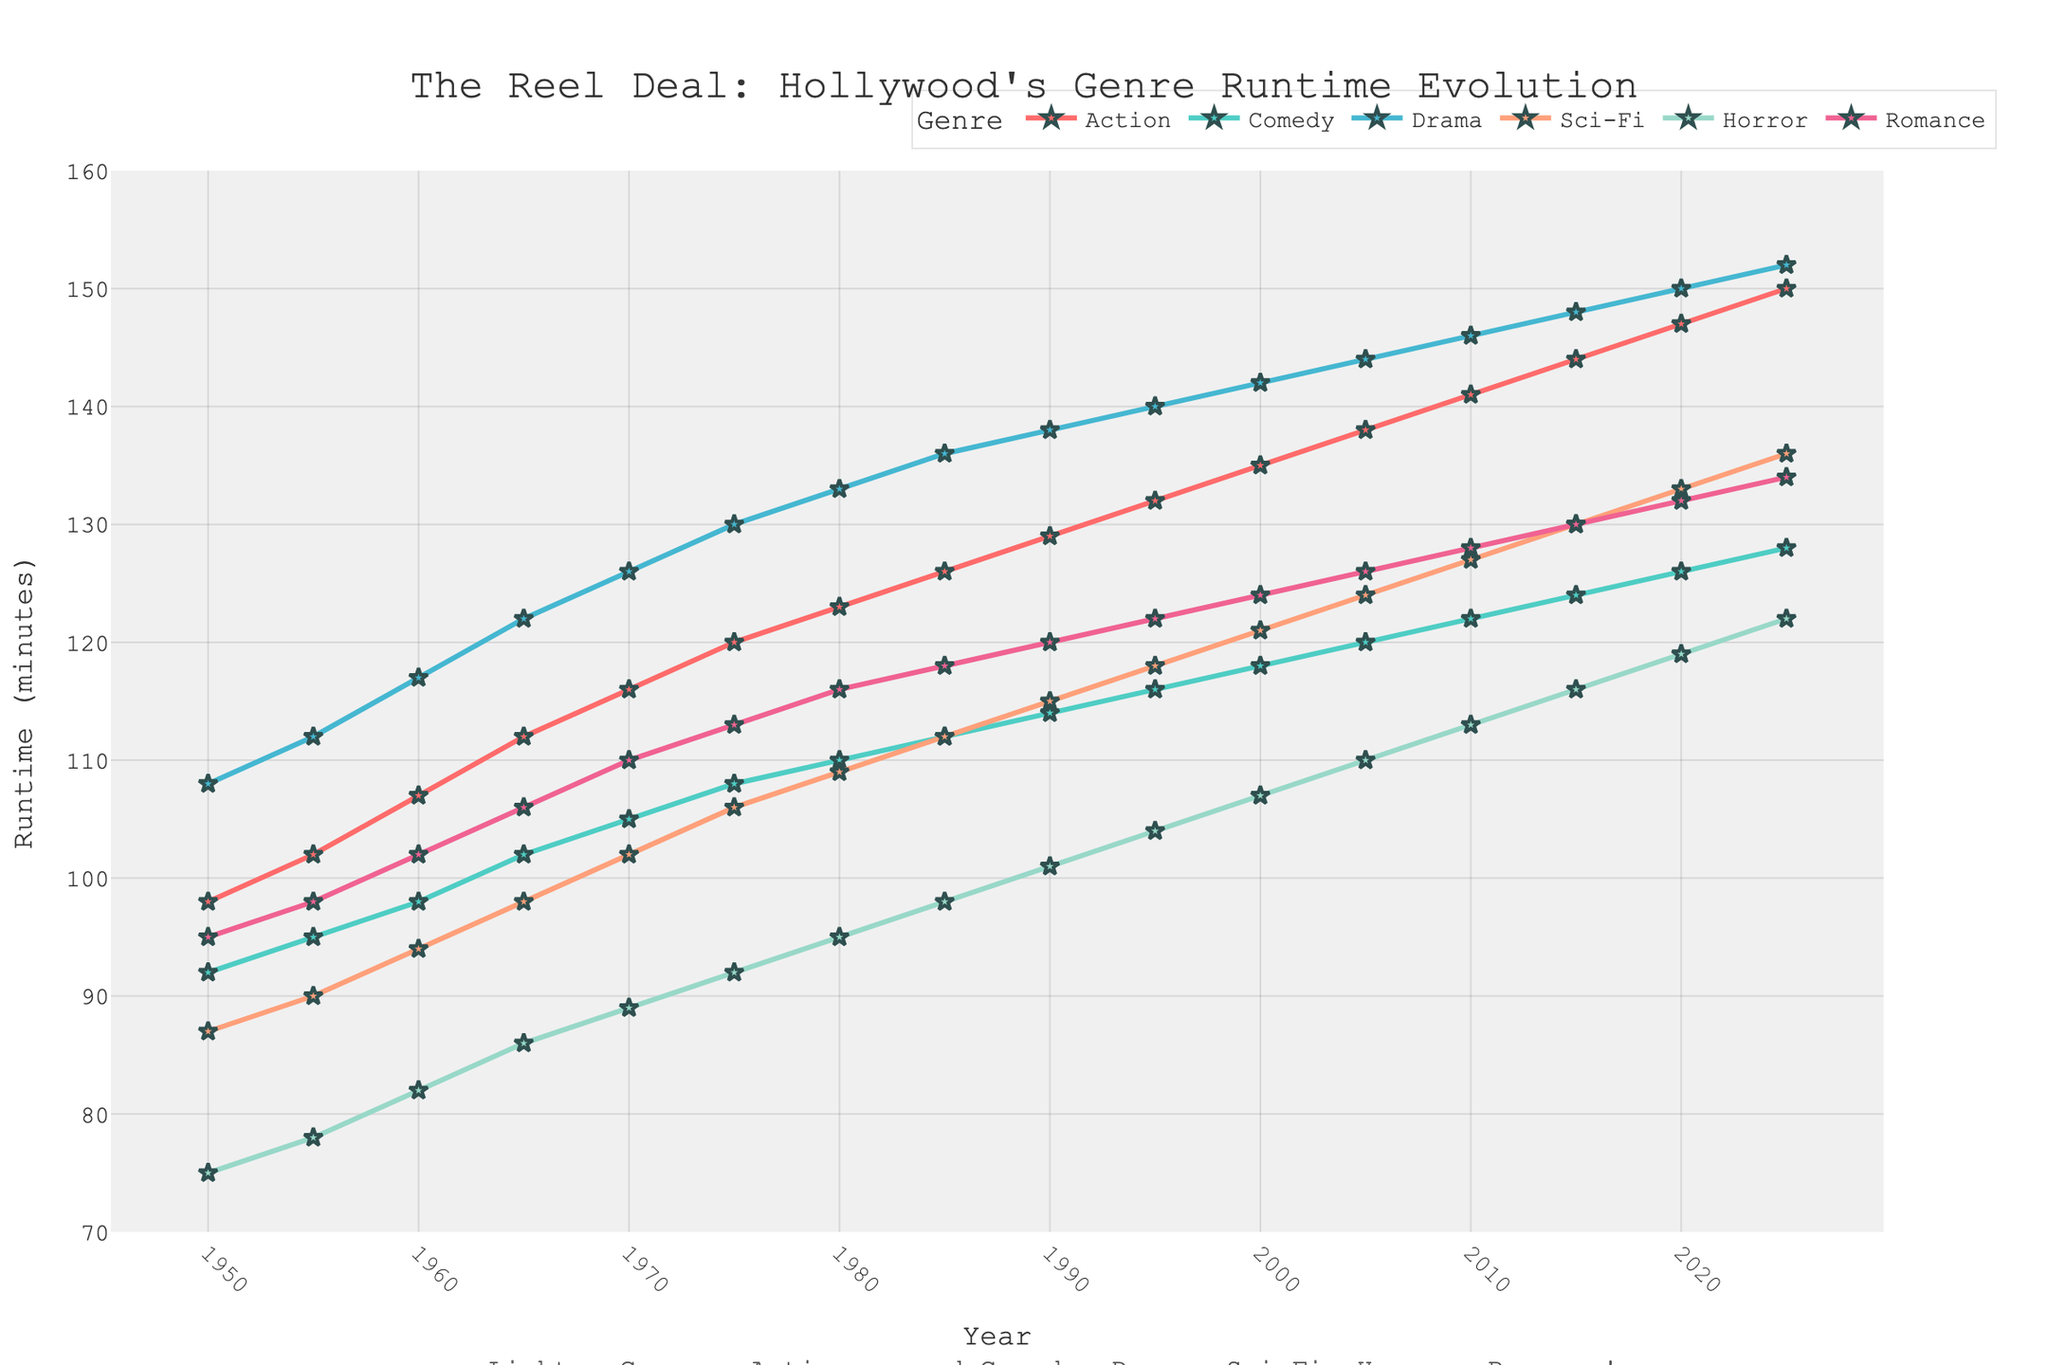Which genre had the longest runtime in 2020? To find the genre with the longest runtime in 2020, look at the year 2020 on the x-axis and compare the y-values (runtime) for each genre. The highest y-value corresponds to Action, which is 147 minutes.
Answer: Action Which genre saw the highest increase in runtime from 1950 to 2025? Calculate the difference in runtime for each genre between 2025 and 1950. The differences are:
- Action: 150 - 98 = 52
- Comedy: 128 - 92 = 36
- Drama: 152 - 108 = 44
- Sci-Fi: 136 - 87 = 49
- Horror: 122 - 75 = 47
- Romance: 134 - 95 = 39
Sci-Fi saw the highest increase (49 minutes).
Answer: Sci-Fi What is the difference in runtime between the longest and shortest genres in 2025? In 2025, the longest genre is Drama with 152 minutes, and the shortest is Comedy with 128 minutes. The difference is 152 - 128 = 24 minutes.
Answer: 24 minutes Which genre's runtime increased steadily over the entire period? Observe the lines for each genre from 1950 to 2025. The genres that show a steady upward trend without steep dips or flat lines are Action and Drama.
Answer: Action, Drama What is the average runtime of Romance movies in the 21st century (2000-2025)? Calculate the average runtime of Romance movies from 2000 to 2025. The runtimes are:
- 2000: 124
- 2005: 126
- 2010: 128
- 2015: 130
- 2020: 132
- 2025: 134
Sum these values and divide by the number of data points: (124 + 126 + 128 + 130 + 132 + 134) / 6 = 774 / 6 = 129 minutes.
Answer: 129 minutes Which genre had the shortest runtime in 1950? Look at the year 1950 on the x-axis and find the shortest y-value (runtime). The shortest runtime corresponds to Horror, which is 75 minutes.
Answer: Horror What is the range of runtime values for Sci-Fi movies between 1950 and 2025? The minimum and maximum runtimes for Sci-Fi movies between 1950 and 2025 are 87 (in 1950) and 136 (in 2025). The range is calculated as 136 - 87 = 49 minutes.
Answer: 49 minutes From 2000 to 2020, which genre had the most consistent runtime? To determine consistency, observe the genre lines from 2000 to 2020. The line that shows the least fluctuation is for Romance, maintaining a steady increase of 2 minutes every 5 years.
Answer: Romance 